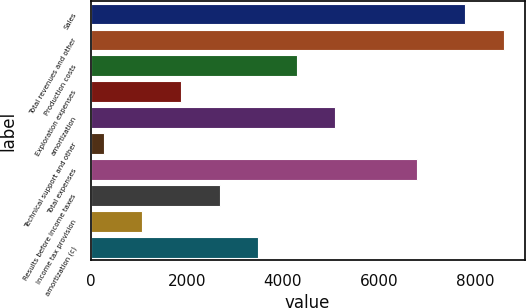Convert chart. <chart><loc_0><loc_0><loc_500><loc_500><bar_chart><fcel>Sales<fcel>Total revenues and other<fcel>Production costs<fcel>Exploration expenses<fcel>amortization<fcel>Technical support and other<fcel>Total expenses<fcel>Results before income taxes<fcel>Income tax provision<fcel>amortization (c)<nl><fcel>7797<fcel>8600.2<fcel>4290<fcel>1880.4<fcel>5093.2<fcel>274<fcel>6797<fcel>2683.6<fcel>1077.2<fcel>3486.8<nl></chart> 